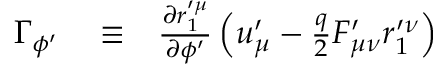Convert formula to latex. <formula><loc_0><loc_0><loc_500><loc_500>\begin{array} { r l r } { \Gamma _ { \phi ^ { \prime } } } & \equiv } & { \frac { \partial r _ { 1 } ^ { \prime \mu } } { \partial \phi ^ { \prime } } \left ( u _ { \mu } ^ { \prime } - \frac { q } { 2 } F _ { \mu \nu } ^ { \prime } r _ { 1 } ^ { \prime \nu } \right ) } \end{array}</formula> 